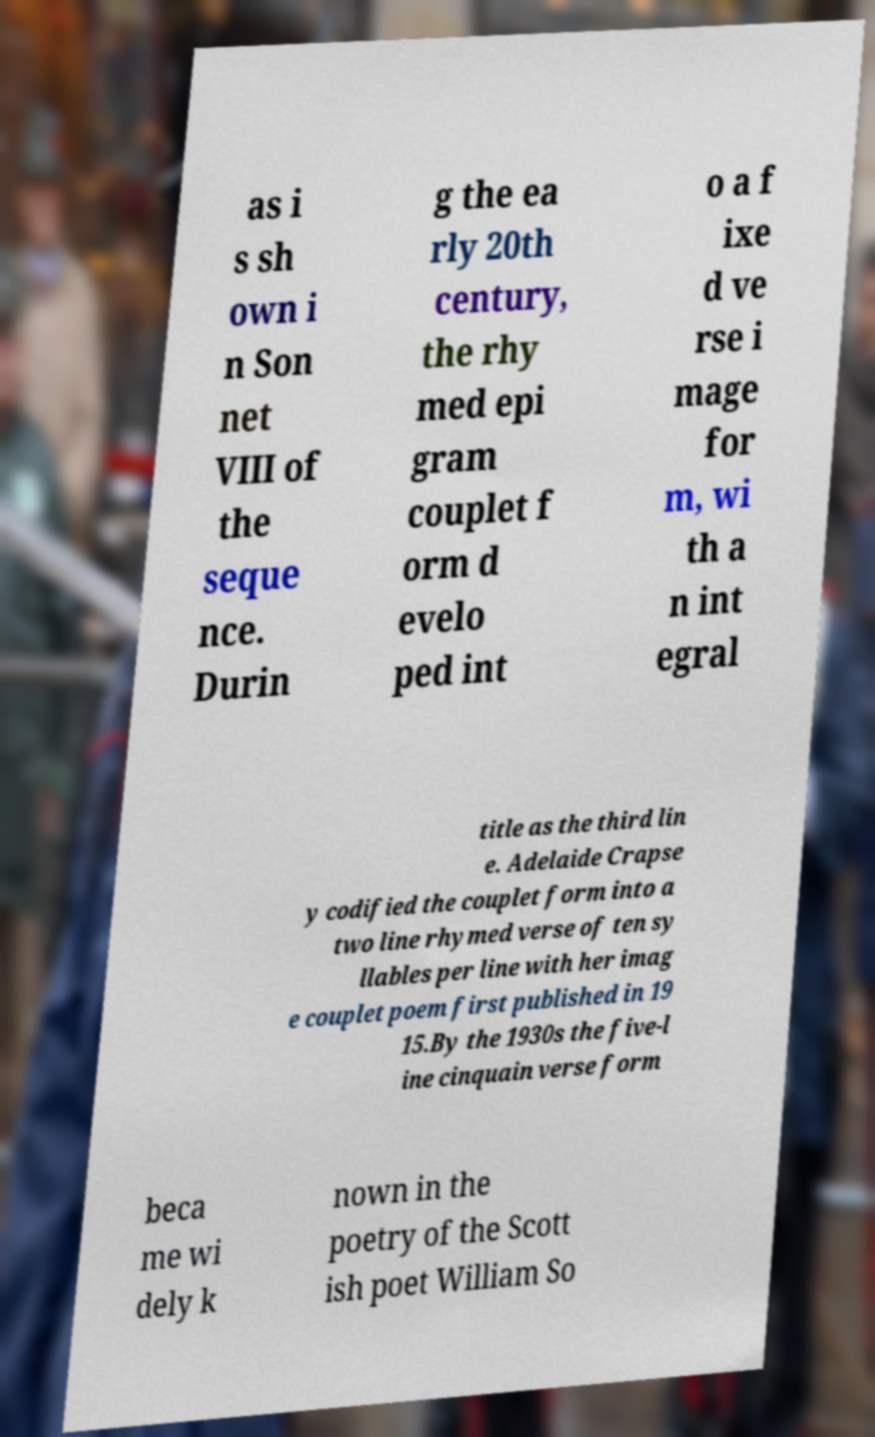Please read and relay the text visible in this image. What does it say? as i s sh own i n Son net VIII of the seque nce. Durin g the ea rly 20th century, the rhy med epi gram couplet f orm d evelo ped int o a f ixe d ve rse i mage for m, wi th a n int egral title as the third lin e. Adelaide Crapse y codified the couplet form into a two line rhymed verse of ten sy llables per line with her imag e couplet poem first published in 19 15.By the 1930s the five-l ine cinquain verse form beca me wi dely k nown in the poetry of the Scott ish poet William So 